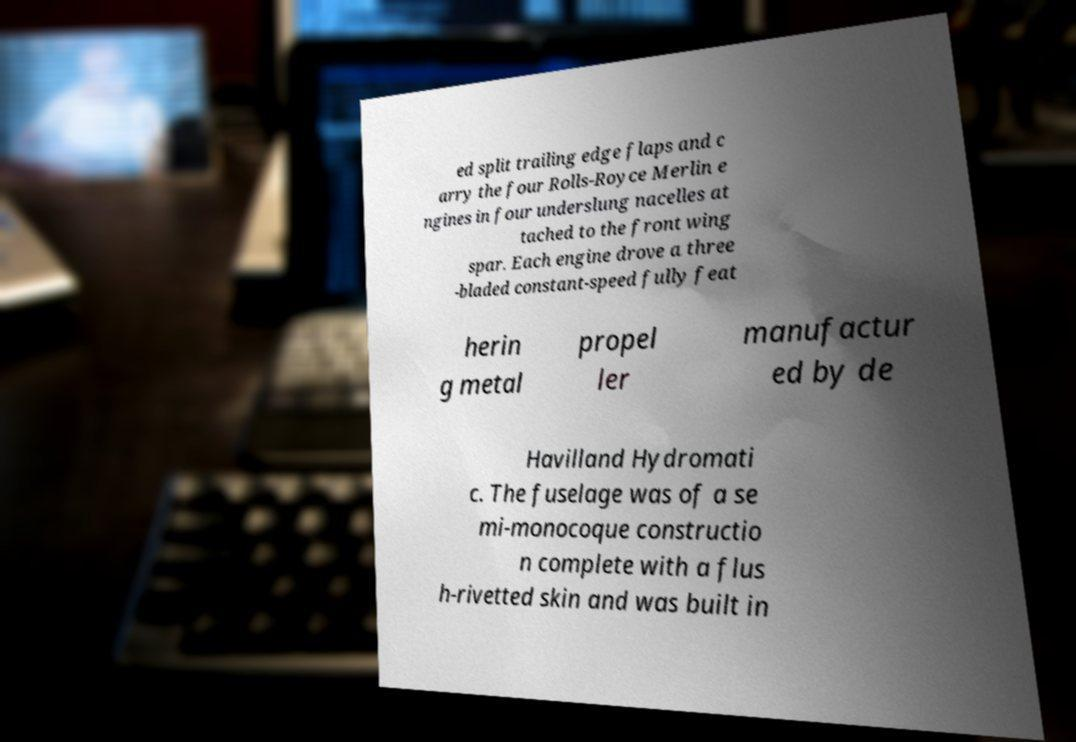For documentation purposes, I need the text within this image transcribed. Could you provide that? ed split trailing edge flaps and c arry the four Rolls-Royce Merlin e ngines in four underslung nacelles at tached to the front wing spar. Each engine drove a three -bladed constant-speed fully feat herin g metal propel ler manufactur ed by de Havilland Hydromati c. The fuselage was of a se mi-monocoque constructio n complete with a flus h-rivetted skin and was built in 